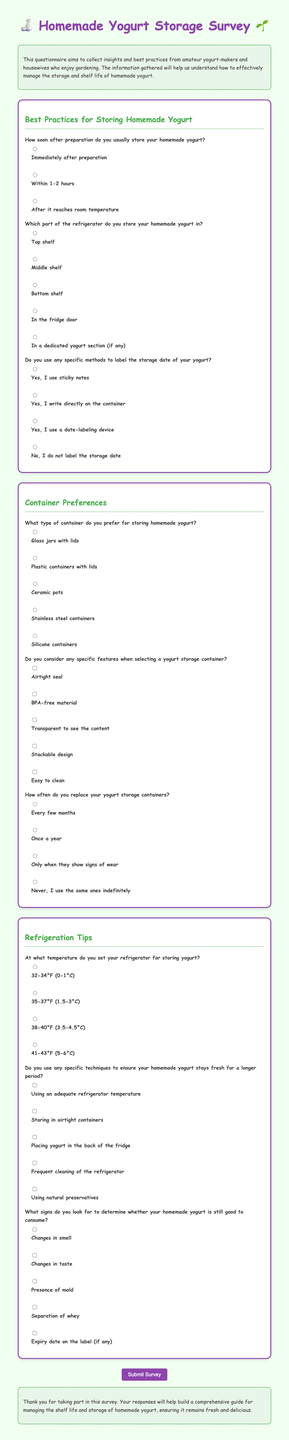How soon after preparation do you usually store your homemade yogurt? The document lists options for how soon after preparation yogurt is stored, including immediately after, within 1-2 hours, or after reaching room temperature.
Answer: Immediately after preparation Which part of the refrigerator do you store your homemade yogurt in? The document provides different options for the location of yogurt storage in the refrigerator, including the top shelf, middle shelf, bottom shelf, fridge door, or a dedicated yogurt section.
Answer: Top shelf What type of container do you prefer for storing homemade yogurt? The document outlines various container preferences for yogurt storage, including glass jars, plastic containers, ceramic pots, stainless steel containers, or silicone containers.
Answer: Glass jars with lids At what temperature do you set your refrigerator for storing yogurt? The document includes temperature settings options for the refrigerator, such as 32-34°F, 35-37°F, 38-40°F, or 41-43°F.
Answer: 35-37°F What signs do you look for to determine whether your homemade yogurt is still good to consume? The document lists signs of spoilage, including changes in smell, taste, presence of mold, whey separation, and expiry date on the label.
Answer: Changes in smell Do you use any specific methods to label the storage date of your yogurt? The document mentions various methods for labeling yogurt's storage date, including sticky notes, writing on the container, or using a date-labeling device.
Answer: Yes, I use sticky notes 